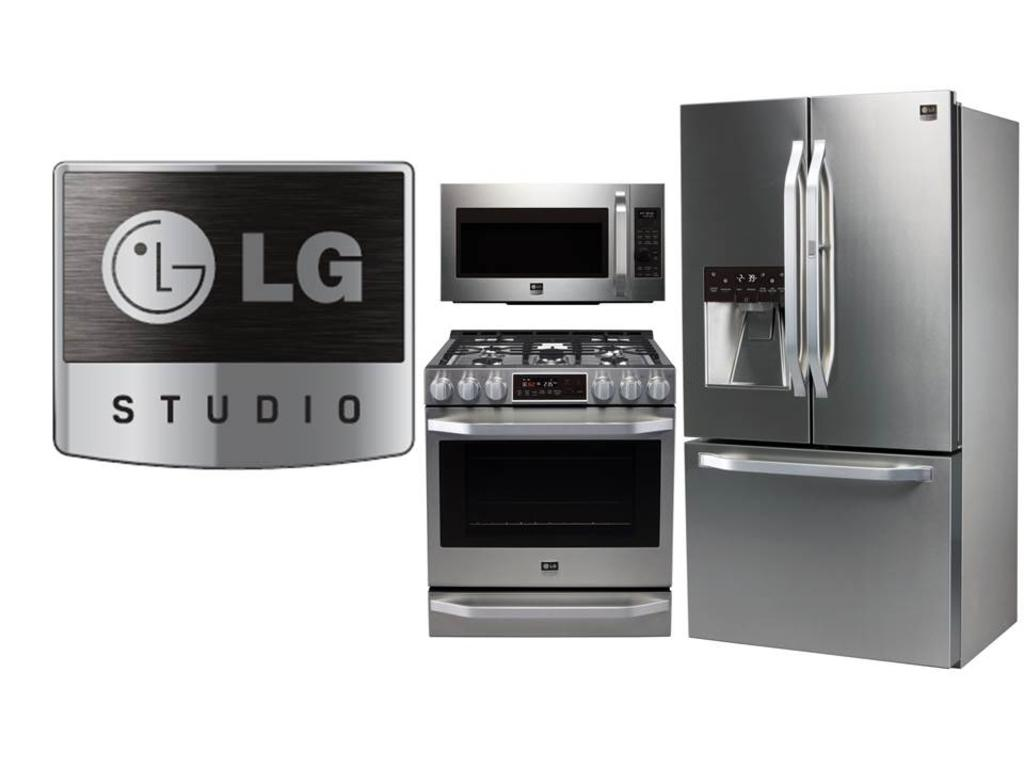<image>
Share a concise interpretation of the image provided. A stainless steel fridge, Stove, and Microwave from LG Studio. 